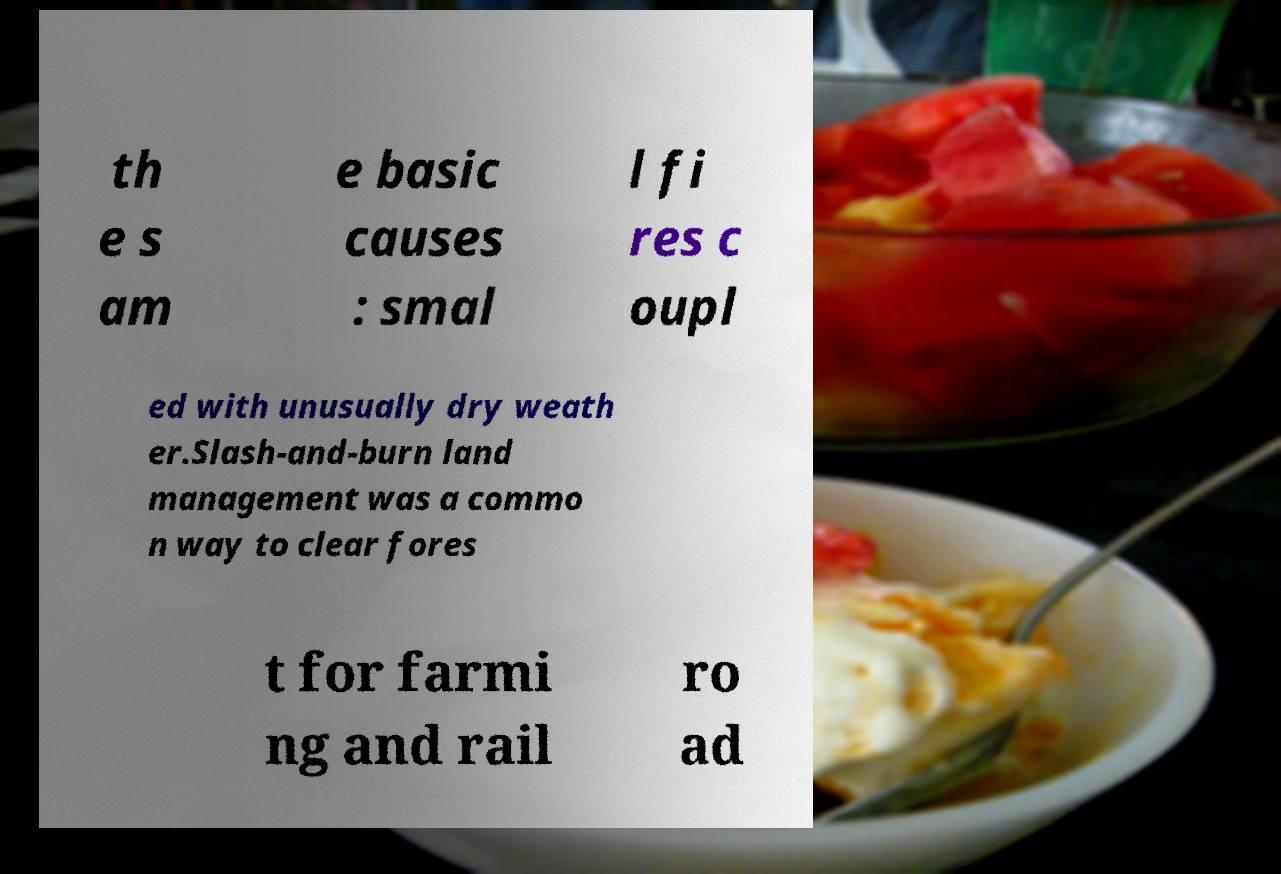Please identify and transcribe the text found in this image. th e s am e basic causes : smal l fi res c oupl ed with unusually dry weath er.Slash-and-burn land management was a commo n way to clear fores t for farmi ng and rail ro ad 